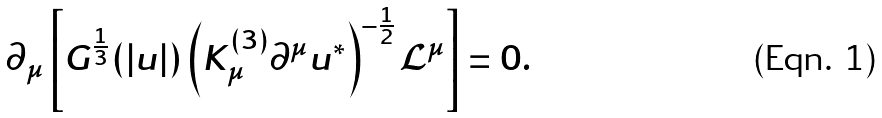<formula> <loc_0><loc_0><loc_500><loc_500>\partial _ { \mu } \left [ G ^ { \frac { 1 } { 3 } } ( | u | ) \left ( K ^ { ( 3 ) } _ { \mu } \partial ^ { \mu } u ^ { * } \right ) ^ { - \frac { 1 } { 2 } } \mathcal { L } ^ { \mu } \right ] = 0 .</formula> 